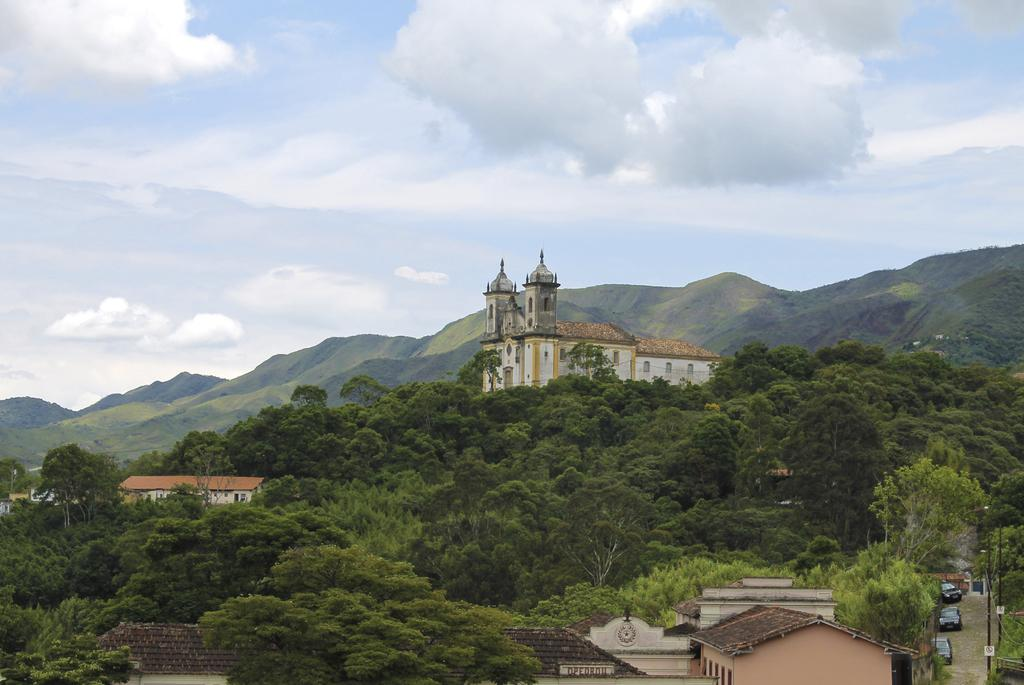What type of vegetation can be seen in the image? There are trees in the image. What type of structure is present in the image? There is a big house in the image. What is the condition of the sky in the image? The sky is cloudy in the image. What type of anger can be seen on the man's face in the image? There is no man present in the image, and therefore no facial expression to analyze. What type of loaf is being baked in the image? There is no loaf or baking activity present in the image. 